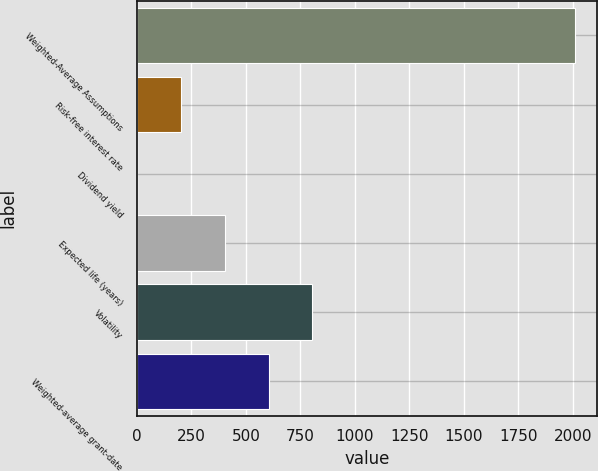<chart> <loc_0><loc_0><loc_500><loc_500><bar_chart><fcel>Weighted-Average Assumptions<fcel>Risk-free interest rate<fcel>Dividend yield<fcel>Expected life (years)<fcel>Volatility<fcel>Weighted-average grant-date<nl><fcel>2008<fcel>202.06<fcel>1.4<fcel>402.72<fcel>804.04<fcel>603.38<nl></chart> 